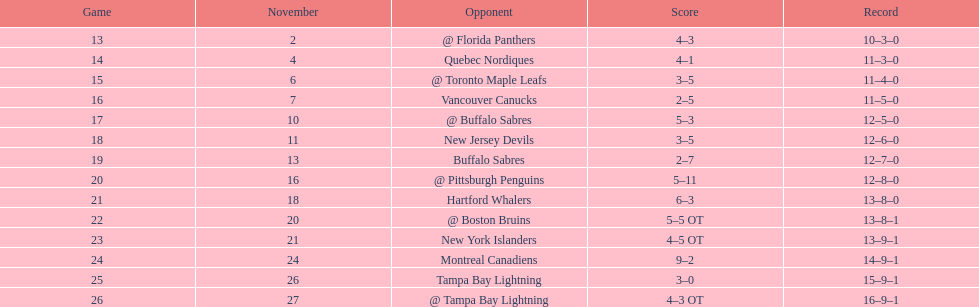Which was the only team in the atlantic division in the 1993-1994 season to acquire less points than the philadelphia flyers? Tampa Bay Lightning. 